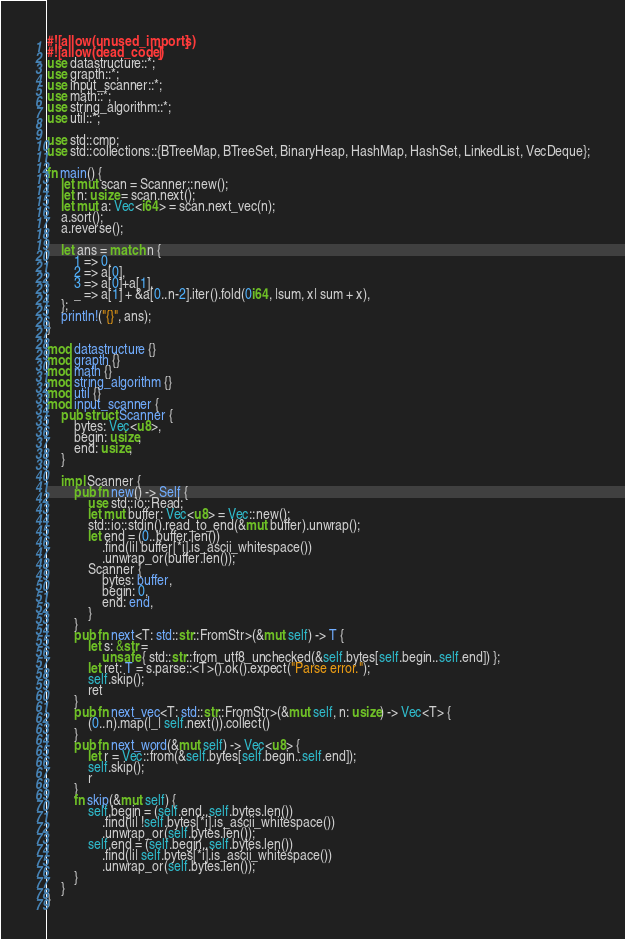<code> <loc_0><loc_0><loc_500><loc_500><_Rust_>#![allow(unused_imports)]
#![allow(dead_code)]
use datastructure::*;
use grapth::*;
use input_scanner::*;
use math::*;
use string_algorithm::*;
use util::*;

use std::cmp;
use std::collections::{BTreeMap, BTreeSet, BinaryHeap, HashMap, HashSet, LinkedList, VecDeque};

fn main() {
    let mut scan = Scanner::new();
    let n: usize = scan.next();
    let mut a: Vec<i64> = scan.next_vec(n);
    a.sort();
    a.reverse();

    let ans = match n {
        1 => 0,
        2 => a[0],
        3 => a[0]+a[1],
        _ => a[1] + &a[0..n-2].iter().fold(0i64, |sum, x| sum + x),
    };
    println!("{}", ans);
}

mod datastructure {}
mod grapth {}
mod math {}
mod string_algorithm {}
mod util {}
mod input_scanner {
    pub struct Scanner {
        bytes: Vec<u8>,
        begin: usize,
        end: usize,
    }

    impl Scanner {
        pub fn new() -> Self {
            use std::io::Read;
            let mut buffer: Vec<u8> = Vec::new();
            std::io::stdin().read_to_end(&mut buffer).unwrap();
            let end = (0..buffer.len())
                .find(|i| buffer[*i].is_ascii_whitespace())
                .unwrap_or(buffer.len());
            Scanner {
                bytes: buffer,
                begin: 0,
                end: end,
            }
        }
        pub fn next<T: std::str::FromStr>(&mut self) -> T {
            let s: &str =
                unsafe { std::str::from_utf8_unchecked(&self.bytes[self.begin..self.end]) };
            let ret: T = s.parse::<T>().ok().expect("Parse error.");
            self.skip();
            ret
        }
        pub fn next_vec<T: std::str::FromStr>(&mut self, n: usize) -> Vec<T> {
            (0..n).map(|_| self.next()).collect()
        }
        pub fn next_word(&mut self) -> Vec<u8> {
            let r = Vec::from(&self.bytes[self.begin..self.end]);
            self.skip();
            r
        }
        fn skip(&mut self) {
            self.begin = (self.end..self.bytes.len())
                .find(|i| !self.bytes[*i].is_ascii_whitespace())
                .unwrap_or(self.bytes.len());
            self.end = (self.begin..self.bytes.len())
                .find(|i| self.bytes[*i].is_ascii_whitespace())
                .unwrap_or(self.bytes.len());
        }
    }
}
</code> 